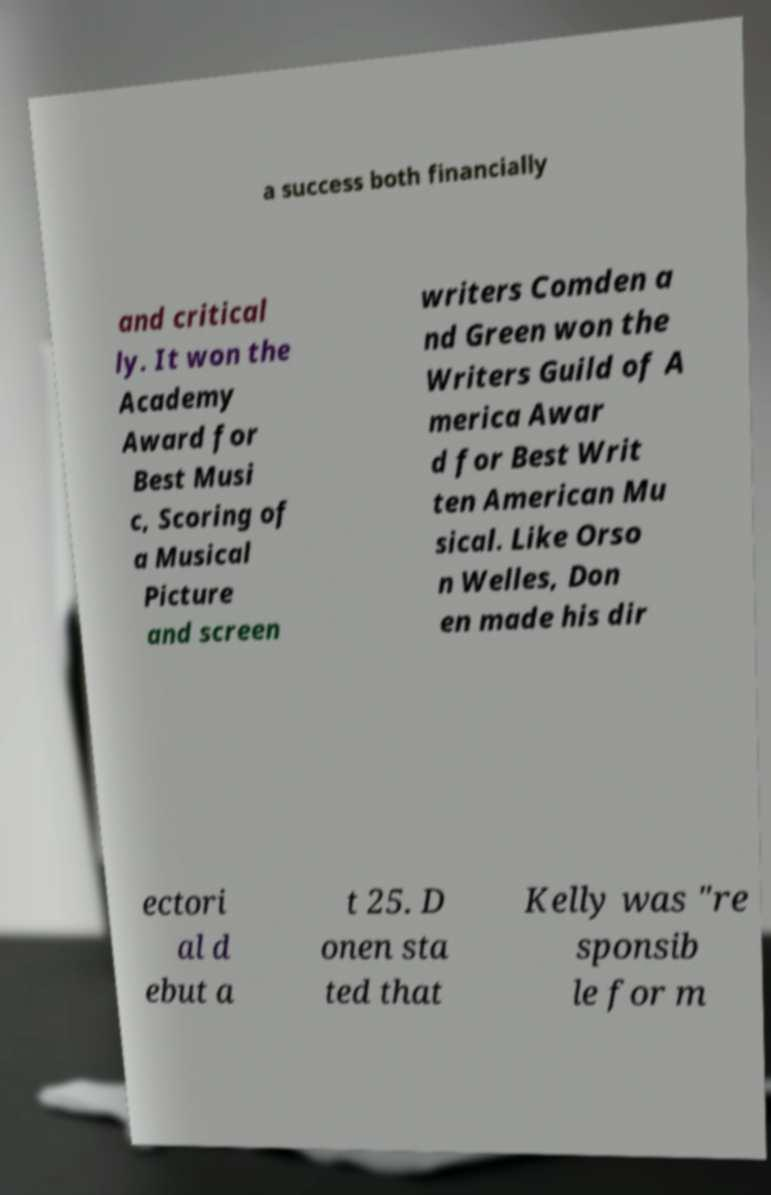Can you accurately transcribe the text from the provided image for me? a success both financially and critical ly. It won the Academy Award for Best Musi c, Scoring of a Musical Picture and screen writers Comden a nd Green won the Writers Guild of A merica Awar d for Best Writ ten American Mu sical. Like Orso n Welles, Don en made his dir ectori al d ebut a t 25. D onen sta ted that Kelly was "re sponsib le for m 